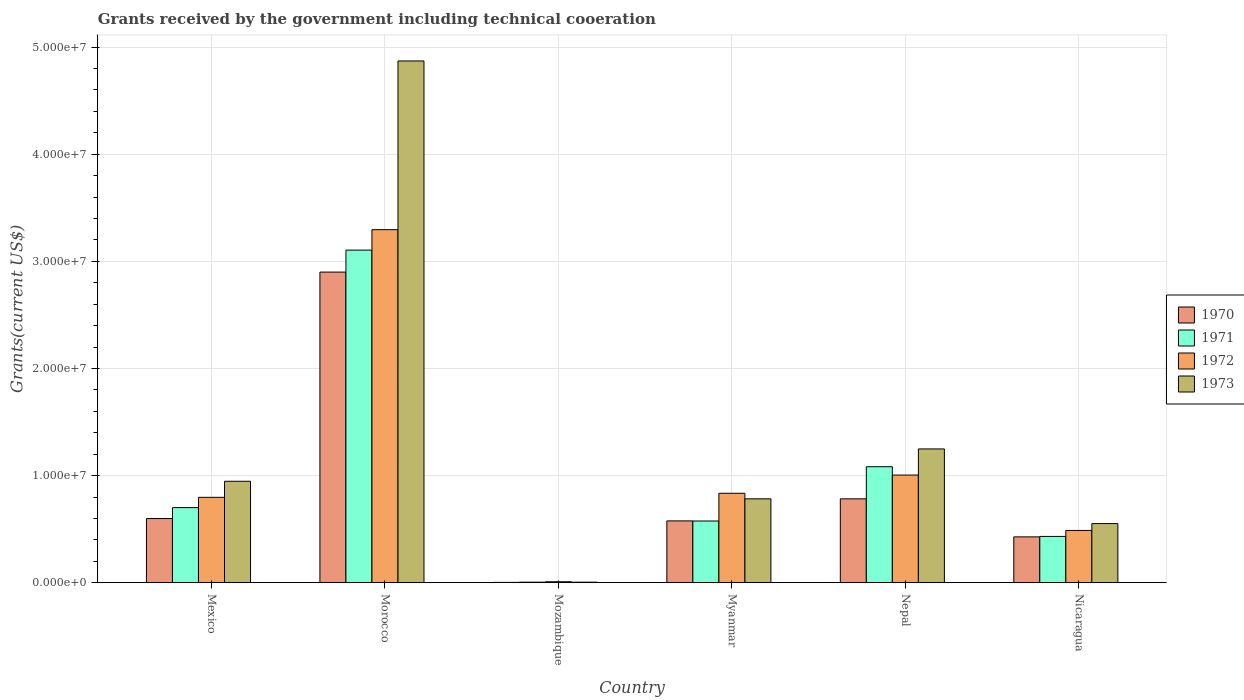Are the number of bars per tick equal to the number of legend labels?
Your response must be concise. Yes. In how many cases, is the number of bars for a given country not equal to the number of legend labels?
Provide a succinct answer. 0. What is the total grants received by the government in 1972 in Mexico?
Make the answer very short. 7.97e+06. Across all countries, what is the maximum total grants received by the government in 1970?
Offer a terse response. 2.90e+07. In which country was the total grants received by the government in 1970 maximum?
Ensure brevity in your answer.  Morocco. In which country was the total grants received by the government in 1971 minimum?
Your answer should be compact. Mozambique. What is the total total grants received by the government in 1971 in the graph?
Offer a very short reply. 5.90e+07. What is the difference between the total grants received by the government in 1972 in Morocco and that in Myanmar?
Provide a short and direct response. 2.46e+07. What is the difference between the total grants received by the government in 1972 in Nepal and the total grants received by the government in 1971 in Mexico?
Offer a very short reply. 3.04e+06. What is the average total grants received by the government in 1973 per country?
Offer a very short reply. 1.40e+07. What is the difference between the total grants received by the government of/in 1973 and total grants received by the government of/in 1972 in Nepal?
Your response must be concise. 2.44e+06. In how many countries, is the total grants received by the government in 1972 greater than 36000000 US$?
Ensure brevity in your answer.  0. What is the ratio of the total grants received by the government in 1970 in Morocco to that in Nicaragua?
Keep it short and to the point. 6.78. What is the difference between the highest and the second highest total grants received by the government in 1973?
Your response must be concise. 3.62e+07. What is the difference between the highest and the lowest total grants received by the government in 1972?
Offer a very short reply. 3.29e+07. Is the sum of the total grants received by the government in 1971 in Mexico and Mozambique greater than the maximum total grants received by the government in 1972 across all countries?
Provide a succinct answer. No. Is it the case that in every country, the sum of the total grants received by the government in 1972 and total grants received by the government in 1970 is greater than the sum of total grants received by the government in 1971 and total grants received by the government in 1973?
Your answer should be compact. No. What does the 4th bar from the right in Nepal represents?
Provide a short and direct response. 1970. How many bars are there?
Offer a very short reply. 24. Does the graph contain grids?
Keep it short and to the point. Yes. Where does the legend appear in the graph?
Your answer should be compact. Center right. What is the title of the graph?
Make the answer very short. Grants received by the government including technical cooeration. Does "2004" appear as one of the legend labels in the graph?
Offer a terse response. No. What is the label or title of the X-axis?
Ensure brevity in your answer.  Country. What is the label or title of the Y-axis?
Offer a terse response. Grants(current US$). What is the Grants(current US$) of 1970 in Mexico?
Provide a short and direct response. 5.99e+06. What is the Grants(current US$) of 1971 in Mexico?
Make the answer very short. 7.01e+06. What is the Grants(current US$) of 1972 in Mexico?
Offer a very short reply. 7.97e+06. What is the Grants(current US$) in 1973 in Mexico?
Offer a terse response. 9.47e+06. What is the Grants(current US$) of 1970 in Morocco?
Give a very brief answer. 2.90e+07. What is the Grants(current US$) of 1971 in Morocco?
Make the answer very short. 3.10e+07. What is the Grants(current US$) in 1972 in Morocco?
Offer a terse response. 3.30e+07. What is the Grants(current US$) of 1973 in Morocco?
Ensure brevity in your answer.  4.87e+07. What is the Grants(current US$) of 1972 in Mozambique?
Keep it short and to the point. 9.00e+04. What is the Grants(current US$) of 1973 in Mozambique?
Ensure brevity in your answer.  5.00e+04. What is the Grants(current US$) in 1970 in Myanmar?
Make the answer very short. 5.77e+06. What is the Grants(current US$) in 1971 in Myanmar?
Your answer should be very brief. 5.76e+06. What is the Grants(current US$) of 1972 in Myanmar?
Offer a very short reply. 8.35e+06. What is the Grants(current US$) in 1973 in Myanmar?
Offer a very short reply. 7.83e+06. What is the Grants(current US$) of 1970 in Nepal?
Make the answer very short. 7.83e+06. What is the Grants(current US$) of 1971 in Nepal?
Offer a very short reply. 1.08e+07. What is the Grants(current US$) in 1972 in Nepal?
Your response must be concise. 1.00e+07. What is the Grants(current US$) in 1973 in Nepal?
Provide a short and direct response. 1.25e+07. What is the Grants(current US$) in 1970 in Nicaragua?
Provide a short and direct response. 4.28e+06. What is the Grants(current US$) in 1971 in Nicaragua?
Your answer should be very brief. 4.32e+06. What is the Grants(current US$) in 1972 in Nicaragua?
Provide a succinct answer. 4.88e+06. What is the Grants(current US$) in 1973 in Nicaragua?
Offer a very short reply. 5.52e+06. Across all countries, what is the maximum Grants(current US$) of 1970?
Provide a short and direct response. 2.90e+07. Across all countries, what is the maximum Grants(current US$) in 1971?
Offer a very short reply. 3.10e+07. Across all countries, what is the maximum Grants(current US$) of 1972?
Provide a succinct answer. 3.30e+07. Across all countries, what is the maximum Grants(current US$) in 1973?
Provide a short and direct response. 4.87e+07. Across all countries, what is the minimum Grants(current US$) of 1970?
Offer a very short reply. 3.00e+04. Across all countries, what is the minimum Grants(current US$) in 1971?
Give a very brief answer. 5.00e+04. Across all countries, what is the minimum Grants(current US$) of 1972?
Keep it short and to the point. 9.00e+04. Across all countries, what is the minimum Grants(current US$) in 1973?
Keep it short and to the point. 5.00e+04. What is the total Grants(current US$) of 1970 in the graph?
Ensure brevity in your answer.  5.29e+07. What is the total Grants(current US$) of 1971 in the graph?
Keep it short and to the point. 5.90e+07. What is the total Grants(current US$) in 1972 in the graph?
Provide a succinct answer. 6.43e+07. What is the total Grants(current US$) in 1973 in the graph?
Ensure brevity in your answer.  8.41e+07. What is the difference between the Grants(current US$) in 1970 in Mexico and that in Morocco?
Give a very brief answer. -2.30e+07. What is the difference between the Grants(current US$) in 1971 in Mexico and that in Morocco?
Your answer should be very brief. -2.40e+07. What is the difference between the Grants(current US$) in 1972 in Mexico and that in Morocco?
Offer a terse response. -2.50e+07. What is the difference between the Grants(current US$) in 1973 in Mexico and that in Morocco?
Provide a short and direct response. -3.92e+07. What is the difference between the Grants(current US$) in 1970 in Mexico and that in Mozambique?
Give a very brief answer. 5.96e+06. What is the difference between the Grants(current US$) of 1971 in Mexico and that in Mozambique?
Offer a very short reply. 6.96e+06. What is the difference between the Grants(current US$) of 1972 in Mexico and that in Mozambique?
Provide a succinct answer. 7.88e+06. What is the difference between the Grants(current US$) of 1973 in Mexico and that in Mozambique?
Offer a terse response. 9.42e+06. What is the difference between the Grants(current US$) in 1971 in Mexico and that in Myanmar?
Provide a short and direct response. 1.25e+06. What is the difference between the Grants(current US$) in 1972 in Mexico and that in Myanmar?
Provide a short and direct response. -3.80e+05. What is the difference between the Grants(current US$) of 1973 in Mexico and that in Myanmar?
Offer a terse response. 1.64e+06. What is the difference between the Grants(current US$) of 1970 in Mexico and that in Nepal?
Offer a terse response. -1.84e+06. What is the difference between the Grants(current US$) of 1971 in Mexico and that in Nepal?
Keep it short and to the point. -3.82e+06. What is the difference between the Grants(current US$) in 1972 in Mexico and that in Nepal?
Provide a short and direct response. -2.08e+06. What is the difference between the Grants(current US$) of 1973 in Mexico and that in Nepal?
Provide a short and direct response. -3.02e+06. What is the difference between the Grants(current US$) of 1970 in Mexico and that in Nicaragua?
Offer a very short reply. 1.71e+06. What is the difference between the Grants(current US$) in 1971 in Mexico and that in Nicaragua?
Your answer should be very brief. 2.69e+06. What is the difference between the Grants(current US$) in 1972 in Mexico and that in Nicaragua?
Your answer should be compact. 3.09e+06. What is the difference between the Grants(current US$) of 1973 in Mexico and that in Nicaragua?
Make the answer very short. 3.95e+06. What is the difference between the Grants(current US$) of 1970 in Morocco and that in Mozambique?
Provide a succinct answer. 2.90e+07. What is the difference between the Grants(current US$) in 1971 in Morocco and that in Mozambique?
Provide a succinct answer. 3.10e+07. What is the difference between the Grants(current US$) in 1972 in Morocco and that in Mozambique?
Offer a very short reply. 3.29e+07. What is the difference between the Grants(current US$) in 1973 in Morocco and that in Mozambique?
Your answer should be compact. 4.87e+07. What is the difference between the Grants(current US$) in 1970 in Morocco and that in Myanmar?
Provide a short and direct response. 2.32e+07. What is the difference between the Grants(current US$) in 1971 in Morocco and that in Myanmar?
Offer a very short reply. 2.53e+07. What is the difference between the Grants(current US$) of 1972 in Morocco and that in Myanmar?
Keep it short and to the point. 2.46e+07. What is the difference between the Grants(current US$) in 1973 in Morocco and that in Myanmar?
Make the answer very short. 4.09e+07. What is the difference between the Grants(current US$) in 1970 in Morocco and that in Nepal?
Give a very brief answer. 2.12e+07. What is the difference between the Grants(current US$) in 1971 in Morocco and that in Nepal?
Provide a succinct answer. 2.02e+07. What is the difference between the Grants(current US$) in 1972 in Morocco and that in Nepal?
Keep it short and to the point. 2.29e+07. What is the difference between the Grants(current US$) of 1973 in Morocco and that in Nepal?
Your response must be concise. 3.62e+07. What is the difference between the Grants(current US$) of 1970 in Morocco and that in Nicaragua?
Your response must be concise. 2.47e+07. What is the difference between the Grants(current US$) in 1971 in Morocco and that in Nicaragua?
Your response must be concise. 2.67e+07. What is the difference between the Grants(current US$) in 1972 in Morocco and that in Nicaragua?
Offer a very short reply. 2.81e+07. What is the difference between the Grants(current US$) of 1973 in Morocco and that in Nicaragua?
Give a very brief answer. 4.32e+07. What is the difference between the Grants(current US$) of 1970 in Mozambique and that in Myanmar?
Ensure brevity in your answer.  -5.74e+06. What is the difference between the Grants(current US$) of 1971 in Mozambique and that in Myanmar?
Provide a succinct answer. -5.71e+06. What is the difference between the Grants(current US$) of 1972 in Mozambique and that in Myanmar?
Your response must be concise. -8.26e+06. What is the difference between the Grants(current US$) of 1973 in Mozambique and that in Myanmar?
Your answer should be compact. -7.78e+06. What is the difference between the Grants(current US$) in 1970 in Mozambique and that in Nepal?
Your answer should be very brief. -7.80e+06. What is the difference between the Grants(current US$) in 1971 in Mozambique and that in Nepal?
Offer a very short reply. -1.08e+07. What is the difference between the Grants(current US$) of 1972 in Mozambique and that in Nepal?
Offer a terse response. -9.96e+06. What is the difference between the Grants(current US$) of 1973 in Mozambique and that in Nepal?
Keep it short and to the point. -1.24e+07. What is the difference between the Grants(current US$) of 1970 in Mozambique and that in Nicaragua?
Your answer should be very brief. -4.25e+06. What is the difference between the Grants(current US$) of 1971 in Mozambique and that in Nicaragua?
Provide a short and direct response. -4.27e+06. What is the difference between the Grants(current US$) in 1972 in Mozambique and that in Nicaragua?
Ensure brevity in your answer.  -4.79e+06. What is the difference between the Grants(current US$) of 1973 in Mozambique and that in Nicaragua?
Make the answer very short. -5.47e+06. What is the difference between the Grants(current US$) of 1970 in Myanmar and that in Nepal?
Offer a terse response. -2.06e+06. What is the difference between the Grants(current US$) of 1971 in Myanmar and that in Nepal?
Ensure brevity in your answer.  -5.07e+06. What is the difference between the Grants(current US$) in 1972 in Myanmar and that in Nepal?
Your answer should be very brief. -1.70e+06. What is the difference between the Grants(current US$) in 1973 in Myanmar and that in Nepal?
Make the answer very short. -4.66e+06. What is the difference between the Grants(current US$) in 1970 in Myanmar and that in Nicaragua?
Offer a terse response. 1.49e+06. What is the difference between the Grants(current US$) in 1971 in Myanmar and that in Nicaragua?
Offer a very short reply. 1.44e+06. What is the difference between the Grants(current US$) of 1972 in Myanmar and that in Nicaragua?
Give a very brief answer. 3.47e+06. What is the difference between the Grants(current US$) of 1973 in Myanmar and that in Nicaragua?
Ensure brevity in your answer.  2.31e+06. What is the difference between the Grants(current US$) of 1970 in Nepal and that in Nicaragua?
Your answer should be compact. 3.55e+06. What is the difference between the Grants(current US$) in 1971 in Nepal and that in Nicaragua?
Offer a very short reply. 6.51e+06. What is the difference between the Grants(current US$) of 1972 in Nepal and that in Nicaragua?
Provide a succinct answer. 5.17e+06. What is the difference between the Grants(current US$) of 1973 in Nepal and that in Nicaragua?
Offer a very short reply. 6.97e+06. What is the difference between the Grants(current US$) in 1970 in Mexico and the Grants(current US$) in 1971 in Morocco?
Provide a succinct answer. -2.51e+07. What is the difference between the Grants(current US$) of 1970 in Mexico and the Grants(current US$) of 1972 in Morocco?
Provide a succinct answer. -2.70e+07. What is the difference between the Grants(current US$) in 1970 in Mexico and the Grants(current US$) in 1973 in Morocco?
Offer a very short reply. -4.27e+07. What is the difference between the Grants(current US$) in 1971 in Mexico and the Grants(current US$) in 1972 in Morocco?
Keep it short and to the point. -2.60e+07. What is the difference between the Grants(current US$) of 1971 in Mexico and the Grants(current US$) of 1973 in Morocco?
Ensure brevity in your answer.  -4.17e+07. What is the difference between the Grants(current US$) of 1972 in Mexico and the Grants(current US$) of 1973 in Morocco?
Make the answer very short. -4.07e+07. What is the difference between the Grants(current US$) in 1970 in Mexico and the Grants(current US$) in 1971 in Mozambique?
Make the answer very short. 5.94e+06. What is the difference between the Grants(current US$) in 1970 in Mexico and the Grants(current US$) in 1972 in Mozambique?
Ensure brevity in your answer.  5.90e+06. What is the difference between the Grants(current US$) of 1970 in Mexico and the Grants(current US$) of 1973 in Mozambique?
Provide a succinct answer. 5.94e+06. What is the difference between the Grants(current US$) of 1971 in Mexico and the Grants(current US$) of 1972 in Mozambique?
Your answer should be compact. 6.92e+06. What is the difference between the Grants(current US$) in 1971 in Mexico and the Grants(current US$) in 1973 in Mozambique?
Offer a very short reply. 6.96e+06. What is the difference between the Grants(current US$) in 1972 in Mexico and the Grants(current US$) in 1973 in Mozambique?
Offer a very short reply. 7.92e+06. What is the difference between the Grants(current US$) in 1970 in Mexico and the Grants(current US$) in 1972 in Myanmar?
Offer a terse response. -2.36e+06. What is the difference between the Grants(current US$) of 1970 in Mexico and the Grants(current US$) of 1973 in Myanmar?
Provide a succinct answer. -1.84e+06. What is the difference between the Grants(current US$) in 1971 in Mexico and the Grants(current US$) in 1972 in Myanmar?
Give a very brief answer. -1.34e+06. What is the difference between the Grants(current US$) of 1971 in Mexico and the Grants(current US$) of 1973 in Myanmar?
Offer a very short reply. -8.20e+05. What is the difference between the Grants(current US$) of 1970 in Mexico and the Grants(current US$) of 1971 in Nepal?
Give a very brief answer. -4.84e+06. What is the difference between the Grants(current US$) of 1970 in Mexico and the Grants(current US$) of 1972 in Nepal?
Offer a terse response. -4.06e+06. What is the difference between the Grants(current US$) in 1970 in Mexico and the Grants(current US$) in 1973 in Nepal?
Provide a succinct answer. -6.50e+06. What is the difference between the Grants(current US$) in 1971 in Mexico and the Grants(current US$) in 1972 in Nepal?
Your answer should be very brief. -3.04e+06. What is the difference between the Grants(current US$) in 1971 in Mexico and the Grants(current US$) in 1973 in Nepal?
Keep it short and to the point. -5.48e+06. What is the difference between the Grants(current US$) in 1972 in Mexico and the Grants(current US$) in 1973 in Nepal?
Make the answer very short. -4.52e+06. What is the difference between the Grants(current US$) in 1970 in Mexico and the Grants(current US$) in 1971 in Nicaragua?
Ensure brevity in your answer.  1.67e+06. What is the difference between the Grants(current US$) in 1970 in Mexico and the Grants(current US$) in 1972 in Nicaragua?
Offer a very short reply. 1.11e+06. What is the difference between the Grants(current US$) in 1970 in Mexico and the Grants(current US$) in 1973 in Nicaragua?
Give a very brief answer. 4.70e+05. What is the difference between the Grants(current US$) of 1971 in Mexico and the Grants(current US$) of 1972 in Nicaragua?
Give a very brief answer. 2.13e+06. What is the difference between the Grants(current US$) of 1971 in Mexico and the Grants(current US$) of 1973 in Nicaragua?
Your response must be concise. 1.49e+06. What is the difference between the Grants(current US$) in 1972 in Mexico and the Grants(current US$) in 1973 in Nicaragua?
Ensure brevity in your answer.  2.45e+06. What is the difference between the Grants(current US$) in 1970 in Morocco and the Grants(current US$) in 1971 in Mozambique?
Your response must be concise. 2.90e+07. What is the difference between the Grants(current US$) in 1970 in Morocco and the Grants(current US$) in 1972 in Mozambique?
Give a very brief answer. 2.89e+07. What is the difference between the Grants(current US$) of 1970 in Morocco and the Grants(current US$) of 1973 in Mozambique?
Keep it short and to the point. 2.90e+07. What is the difference between the Grants(current US$) in 1971 in Morocco and the Grants(current US$) in 1972 in Mozambique?
Provide a succinct answer. 3.10e+07. What is the difference between the Grants(current US$) of 1971 in Morocco and the Grants(current US$) of 1973 in Mozambique?
Your answer should be compact. 3.10e+07. What is the difference between the Grants(current US$) in 1972 in Morocco and the Grants(current US$) in 1973 in Mozambique?
Your answer should be very brief. 3.29e+07. What is the difference between the Grants(current US$) in 1970 in Morocco and the Grants(current US$) in 1971 in Myanmar?
Provide a short and direct response. 2.32e+07. What is the difference between the Grants(current US$) of 1970 in Morocco and the Grants(current US$) of 1972 in Myanmar?
Give a very brief answer. 2.06e+07. What is the difference between the Grants(current US$) in 1970 in Morocco and the Grants(current US$) in 1973 in Myanmar?
Provide a short and direct response. 2.12e+07. What is the difference between the Grants(current US$) in 1971 in Morocco and the Grants(current US$) in 1972 in Myanmar?
Provide a short and direct response. 2.27e+07. What is the difference between the Grants(current US$) in 1971 in Morocco and the Grants(current US$) in 1973 in Myanmar?
Provide a short and direct response. 2.32e+07. What is the difference between the Grants(current US$) in 1972 in Morocco and the Grants(current US$) in 1973 in Myanmar?
Offer a very short reply. 2.51e+07. What is the difference between the Grants(current US$) in 1970 in Morocco and the Grants(current US$) in 1971 in Nepal?
Keep it short and to the point. 1.82e+07. What is the difference between the Grants(current US$) in 1970 in Morocco and the Grants(current US$) in 1972 in Nepal?
Ensure brevity in your answer.  1.90e+07. What is the difference between the Grants(current US$) in 1970 in Morocco and the Grants(current US$) in 1973 in Nepal?
Provide a short and direct response. 1.65e+07. What is the difference between the Grants(current US$) of 1971 in Morocco and the Grants(current US$) of 1972 in Nepal?
Offer a very short reply. 2.10e+07. What is the difference between the Grants(current US$) in 1971 in Morocco and the Grants(current US$) in 1973 in Nepal?
Ensure brevity in your answer.  1.86e+07. What is the difference between the Grants(current US$) of 1972 in Morocco and the Grants(current US$) of 1973 in Nepal?
Your answer should be compact. 2.05e+07. What is the difference between the Grants(current US$) of 1970 in Morocco and the Grants(current US$) of 1971 in Nicaragua?
Your answer should be very brief. 2.47e+07. What is the difference between the Grants(current US$) in 1970 in Morocco and the Grants(current US$) in 1972 in Nicaragua?
Give a very brief answer. 2.41e+07. What is the difference between the Grants(current US$) in 1970 in Morocco and the Grants(current US$) in 1973 in Nicaragua?
Ensure brevity in your answer.  2.35e+07. What is the difference between the Grants(current US$) in 1971 in Morocco and the Grants(current US$) in 1972 in Nicaragua?
Offer a very short reply. 2.62e+07. What is the difference between the Grants(current US$) of 1971 in Morocco and the Grants(current US$) of 1973 in Nicaragua?
Offer a terse response. 2.55e+07. What is the difference between the Grants(current US$) of 1972 in Morocco and the Grants(current US$) of 1973 in Nicaragua?
Make the answer very short. 2.74e+07. What is the difference between the Grants(current US$) in 1970 in Mozambique and the Grants(current US$) in 1971 in Myanmar?
Keep it short and to the point. -5.73e+06. What is the difference between the Grants(current US$) in 1970 in Mozambique and the Grants(current US$) in 1972 in Myanmar?
Provide a short and direct response. -8.32e+06. What is the difference between the Grants(current US$) in 1970 in Mozambique and the Grants(current US$) in 1973 in Myanmar?
Provide a short and direct response. -7.80e+06. What is the difference between the Grants(current US$) of 1971 in Mozambique and the Grants(current US$) of 1972 in Myanmar?
Your answer should be compact. -8.30e+06. What is the difference between the Grants(current US$) in 1971 in Mozambique and the Grants(current US$) in 1973 in Myanmar?
Offer a very short reply. -7.78e+06. What is the difference between the Grants(current US$) in 1972 in Mozambique and the Grants(current US$) in 1973 in Myanmar?
Keep it short and to the point. -7.74e+06. What is the difference between the Grants(current US$) of 1970 in Mozambique and the Grants(current US$) of 1971 in Nepal?
Offer a very short reply. -1.08e+07. What is the difference between the Grants(current US$) of 1970 in Mozambique and the Grants(current US$) of 1972 in Nepal?
Your answer should be compact. -1.00e+07. What is the difference between the Grants(current US$) of 1970 in Mozambique and the Grants(current US$) of 1973 in Nepal?
Ensure brevity in your answer.  -1.25e+07. What is the difference between the Grants(current US$) in 1971 in Mozambique and the Grants(current US$) in 1972 in Nepal?
Ensure brevity in your answer.  -1.00e+07. What is the difference between the Grants(current US$) of 1971 in Mozambique and the Grants(current US$) of 1973 in Nepal?
Keep it short and to the point. -1.24e+07. What is the difference between the Grants(current US$) of 1972 in Mozambique and the Grants(current US$) of 1973 in Nepal?
Your answer should be compact. -1.24e+07. What is the difference between the Grants(current US$) in 1970 in Mozambique and the Grants(current US$) in 1971 in Nicaragua?
Provide a succinct answer. -4.29e+06. What is the difference between the Grants(current US$) of 1970 in Mozambique and the Grants(current US$) of 1972 in Nicaragua?
Offer a very short reply. -4.85e+06. What is the difference between the Grants(current US$) of 1970 in Mozambique and the Grants(current US$) of 1973 in Nicaragua?
Keep it short and to the point. -5.49e+06. What is the difference between the Grants(current US$) of 1971 in Mozambique and the Grants(current US$) of 1972 in Nicaragua?
Keep it short and to the point. -4.83e+06. What is the difference between the Grants(current US$) in 1971 in Mozambique and the Grants(current US$) in 1973 in Nicaragua?
Provide a short and direct response. -5.47e+06. What is the difference between the Grants(current US$) of 1972 in Mozambique and the Grants(current US$) of 1973 in Nicaragua?
Your answer should be compact. -5.43e+06. What is the difference between the Grants(current US$) in 1970 in Myanmar and the Grants(current US$) in 1971 in Nepal?
Keep it short and to the point. -5.06e+06. What is the difference between the Grants(current US$) in 1970 in Myanmar and the Grants(current US$) in 1972 in Nepal?
Your answer should be very brief. -4.28e+06. What is the difference between the Grants(current US$) in 1970 in Myanmar and the Grants(current US$) in 1973 in Nepal?
Your answer should be very brief. -6.72e+06. What is the difference between the Grants(current US$) in 1971 in Myanmar and the Grants(current US$) in 1972 in Nepal?
Your response must be concise. -4.29e+06. What is the difference between the Grants(current US$) in 1971 in Myanmar and the Grants(current US$) in 1973 in Nepal?
Your response must be concise. -6.73e+06. What is the difference between the Grants(current US$) in 1972 in Myanmar and the Grants(current US$) in 1973 in Nepal?
Your answer should be compact. -4.14e+06. What is the difference between the Grants(current US$) in 1970 in Myanmar and the Grants(current US$) in 1971 in Nicaragua?
Offer a terse response. 1.45e+06. What is the difference between the Grants(current US$) of 1970 in Myanmar and the Grants(current US$) of 1972 in Nicaragua?
Offer a very short reply. 8.90e+05. What is the difference between the Grants(current US$) in 1971 in Myanmar and the Grants(current US$) in 1972 in Nicaragua?
Your answer should be very brief. 8.80e+05. What is the difference between the Grants(current US$) of 1971 in Myanmar and the Grants(current US$) of 1973 in Nicaragua?
Provide a succinct answer. 2.40e+05. What is the difference between the Grants(current US$) in 1972 in Myanmar and the Grants(current US$) in 1973 in Nicaragua?
Offer a terse response. 2.83e+06. What is the difference between the Grants(current US$) of 1970 in Nepal and the Grants(current US$) of 1971 in Nicaragua?
Your response must be concise. 3.51e+06. What is the difference between the Grants(current US$) of 1970 in Nepal and the Grants(current US$) of 1972 in Nicaragua?
Provide a short and direct response. 2.95e+06. What is the difference between the Grants(current US$) of 1970 in Nepal and the Grants(current US$) of 1973 in Nicaragua?
Offer a very short reply. 2.31e+06. What is the difference between the Grants(current US$) in 1971 in Nepal and the Grants(current US$) in 1972 in Nicaragua?
Give a very brief answer. 5.95e+06. What is the difference between the Grants(current US$) in 1971 in Nepal and the Grants(current US$) in 1973 in Nicaragua?
Your response must be concise. 5.31e+06. What is the difference between the Grants(current US$) of 1972 in Nepal and the Grants(current US$) of 1973 in Nicaragua?
Provide a succinct answer. 4.53e+06. What is the average Grants(current US$) in 1970 per country?
Make the answer very short. 8.82e+06. What is the average Grants(current US$) of 1971 per country?
Provide a succinct answer. 9.84e+06. What is the average Grants(current US$) of 1972 per country?
Ensure brevity in your answer.  1.07e+07. What is the average Grants(current US$) in 1973 per country?
Provide a succinct answer. 1.40e+07. What is the difference between the Grants(current US$) in 1970 and Grants(current US$) in 1971 in Mexico?
Your answer should be very brief. -1.02e+06. What is the difference between the Grants(current US$) in 1970 and Grants(current US$) in 1972 in Mexico?
Give a very brief answer. -1.98e+06. What is the difference between the Grants(current US$) of 1970 and Grants(current US$) of 1973 in Mexico?
Your answer should be compact. -3.48e+06. What is the difference between the Grants(current US$) in 1971 and Grants(current US$) in 1972 in Mexico?
Keep it short and to the point. -9.60e+05. What is the difference between the Grants(current US$) of 1971 and Grants(current US$) of 1973 in Mexico?
Your answer should be compact. -2.46e+06. What is the difference between the Grants(current US$) in 1972 and Grants(current US$) in 1973 in Mexico?
Give a very brief answer. -1.50e+06. What is the difference between the Grants(current US$) in 1970 and Grants(current US$) in 1971 in Morocco?
Your response must be concise. -2.05e+06. What is the difference between the Grants(current US$) of 1970 and Grants(current US$) of 1972 in Morocco?
Ensure brevity in your answer.  -3.96e+06. What is the difference between the Grants(current US$) in 1970 and Grants(current US$) in 1973 in Morocco?
Make the answer very short. -1.97e+07. What is the difference between the Grants(current US$) in 1971 and Grants(current US$) in 1972 in Morocco?
Give a very brief answer. -1.91e+06. What is the difference between the Grants(current US$) in 1971 and Grants(current US$) in 1973 in Morocco?
Your answer should be compact. -1.77e+07. What is the difference between the Grants(current US$) of 1972 and Grants(current US$) of 1973 in Morocco?
Ensure brevity in your answer.  -1.58e+07. What is the difference between the Grants(current US$) in 1970 and Grants(current US$) in 1971 in Mozambique?
Make the answer very short. -2.00e+04. What is the difference between the Grants(current US$) in 1970 and Grants(current US$) in 1973 in Mozambique?
Offer a terse response. -2.00e+04. What is the difference between the Grants(current US$) of 1971 and Grants(current US$) of 1972 in Mozambique?
Your answer should be very brief. -4.00e+04. What is the difference between the Grants(current US$) of 1970 and Grants(current US$) of 1971 in Myanmar?
Your response must be concise. 10000. What is the difference between the Grants(current US$) of 1970 and Grants(current US$) of 1972 in Myanmar?
Ensure brevity in your answer.  -2.58e+06. What is the difference between the Grants(current US$) of 1970 and Grants(current US$) of 1973 in Myanmar?
Keep it short and to the point. -2.06e+06. What is the difference between the Grants(current US$) in 1971 and Grants(current US$) in 1972 in Myanmar?
Offer a terse response. -2.59e+06. What is the difference between the Grants(current US$) in 1971 and Grants(current US$) in 1973 in Myanmar?
Provide a succinct answer. -2.07e+06. What is the difference between the Grants(current US$) of 1972 and Grants(current US$) of 1973 in Myanmar?
Provide a short and direct response. 5.20e+05. What is the difference between the Grants(current US$) of 1970 and Grants(current US$) of 1972 in Nepal?
Your answer should be compact. -2.22e+06. What is the difference between the Grants(current US$) of 1970 and Grants(current US$) of 1973 in Nepal?
Your response must be concise. -4.66e+06. What is the difference between the Grants(current US$) in 1971 and Grants(current US$) in 1972 in Nepal?
Provide a succinct answer. 7.80e+05. What is the difference between the Grants(current US$) in 1971 and Grants(current US$) in 1973 in Nepal?
Ensure brevity in your answer.  -1.66e+06. What is the difference between the Grants(current US$) in 1972 and Grants(current US$) in 1973 in Nepal?
Give a very brief answer. -2.44e+06. What is the difference between the Grants(current US$) of 1970 and Grants(current US$) of 1972 in Nicaragua?
Offer a terse response. -6.00e+05. What is the difference between the Grants(current US$) in 1970 and Grants(current US$) in 1973 in Nicaragua?
Provide a succinct answer. -1.24e+06. What is the difference between the Grants(current US$) of 1971 and Grants(current US$) of 1972 in Nicaragua?
Offer a terse response. -5.60e+05. What is the difference between the Grants(current US$) in 1971 and Grants(current US$) in 1973 in Nicaragua?
Offer a terse response. -1.20e+06. What is the difference between the Grants(current US$) in 1972 and Grants(current US$) in 1973 in Nicaragua?
Provide a short and direct response. -6.40e+05. What is the ratio of the Grants(current US$) in 1970 in Mexico to that in Morocco?
Provide a succinct answer. 0.21. What is the ratio of the Grants(current US$) of 1971 in Mexico to that in Morocco?
Your response must be concise. 0.23. What is the ratio of the Grants(current US$) in 1972 in Mexico to that in Morocco?
Provide a succinct answer. 0.24. What is the ratio of the Grants(current US$) of 1973 in Mexico to that in Morocco?
Offer a terse response. 0.19. What is the ratio of the Grants(current US$) of 1970 in Mexico to that in Mozambique?
Offer a terse response. 199.67. What is the ratio of the Grants(current US$) of 1971 in Mexico to that in Mozambique?
Offer a very short reply. 140.2. What is the ratio of the Grants(current US$) in 1972 in Mexico to that in Mozambique?
Ensure brevity in your answer.  88.56. What is the ratio of the Grants(current US$) of 1973 in Mexico to that in Mozambique?
Provide a short and direct response. 189.4. What is the ratio of the Grants(current US$) of 1970 in Mexico to that in Myanmar?
Your answer should be very brief. 1.04. What is the ratio of the Grants(current US$) of 1971 in Mexico to that in Myanmar?
Keep it short and to the point. 1.22. What is the ratio of the Grants(current US$) in 1972 in Mexico to that in Myanmar?
Provide a succinct answer. 0.95. What is the ratio of the Grants(current US$) in 1973 in Mexico to that in Myanmar?
Your answer should be very brief. 1.21. What is the ratio of the Grants(current US$) in 1970 in Mexico to that in Nepal?
Provide a succinct answer. 0.77. What is the ratio of the Grants(current US$) of 1971 in Mexico to that in Nepal?
Provide a short and direct response. 0.65. What is the ratio of the Grants(current US$) in 1972 in Mexico to that in Nepal?
Your answer should be compact. 0.79. What is the ratio of the Grants(current US$) of 1973 in Mexico to that in Nepal?
Offer a terse response. 0.76. What is the ratio of the Grants(current US$) of 1970 in Mexico to that in Nicaragua?
Offer a terse response. 1.4. What is the ratio of the Grants(current US$) in 1971 in Mexico to that in Nicaragua?
Your answer should be very brief. 1.62. What is the ratio of the Grants(current US$) in 1972 in Mexico to that in Nicaragua?
Provide a short and direct response. 1.63. What is the ratio of the Grants(current US$) of 1973 in Mexico to that in Nicaragua?
Your answer should be very brief. 1.72. What is the ratio of the Grants(current US$) of 1970 in Morocco to that in Mozambique?
Your response must be concise. 966.67. What is the ratio of the Grants(current US$) of 1971 in Morocco to that in Mozambique?
Your response must be concise. 621. What is the ratio of the Grants(current US$) in 1972 in Morocco to that in Mozambique?
Make the answer very short. 366.22. What is the ratio of the Grants(current US$) in 1973 in Morocco to that in Mozambique?
Keep it short and to the point. 974.2. What is the ratio of the Grants(current US$) of 1970 in Morocco to that in Myanmar?
Offer a terse response. 5.03. What is the ratio of the Grants(current US$) in 1971 in Morocco to that in Myanmar?
Your answer should be very brief. 5.39. What is the ratio of the Grants(current US$) in 1972 in Morocco to that in Myanmar?
Keep it short and to the point. 3.95. What is the ratio of the Grants(current US$) in 1973 in Morocco to that in Myanmar?
Make the answer very short. 6.22. What is the ratio of the Grants(current US$) in 1970 in Morocco to that in Nepal?
Keep it short and to the point. 3.7. What is the ratio of the Grants(current US$) in 1971 in Morocco to that in Nepal?
Offer a terse response. 2.87. What is the ratio of the Grants(current US$) of 1972 in Morocco to that in Nepal?
Offer a terse response. 3.28. What is the ratio of the Grants(current US$) of 1973 in Morocco to that in Nepal?
Provide a short and direct response. 3.9. What is the ratio of the Grants(current US$) in 1970 in Morocco to that in Nicaragua?
Offer a very short reply. 6.78. What is the ratio of the Grants(current US$) of 1971 in Morocco to that in Nicaragua?
Keep it short and to the point. 7.19. What is the ratio of the Grants(current US$) in 1972 in Morocco to that in Nicaragua?
Make the answer very short. 6.75. What is the ratio of the Grants(current US$) in 1973 in Morocco to that in Nicaragua?
Offer a very short reply. 8.82. What is the ratio of the Grants(current US$) in 1970 in Mozambique to that in Myanmar?
Provide a short and direct response. 0.01. What is the ratio of the Grants(current US$) in 1971 in Mozambique to that in Myanmar?
Provide a short and direct response. 0.01. What is the ratio of the Grants(current US$) in 1972 in Mozambique to that in Myanmar?
Provide a short and direct response. 0.01. What is the ratio of the Grants(current US$) in 1973 in Mozambique to that in Myanmar?
Your answer should be very brief. 0.01. What is the ratio of the Grants(current US$) in 1970 in Mozambique to that in Nepal?
Provide a short and direct response. 0. What is the ratio of the Grants(current US$) in 1971 in Mozambique to that in Nepal?
Provide a succinct answer. 0. What is the ratio of the Grants(current US$) in 1972 in Mozambique to that in Nepal?
Make the answer very short. 0.01. What is the ratio of the Grants(current US$) of 1973 in Mozambique to that in Nepal?
Ensure brevity in your answer.  0. What is the ratio of the Grants(current US$) in 1970 in Mozambique to that in Nicaragua?
Your answer should be compact. 0.01. What is the ratio of the Grants(current US$) of 1971 in Mozambique to that in Nicaragua?
Your answer should be very brief. 0.01. What is the ratio of the Grants(current US$) in 1972 in Mozambique to that in Nicaragua?
Provide a short and direct response. 0.02. What is the ratio of the Grants(current US$) of 1973 in Mozambique to that in Nicaragua?
Give a very brief answer. 0.01. What is the ratio of the Grants(current US$) of 1970 in Myanmar to that in Nepal?
Make the answer very short. 0.74. What is the ratio of the Grants(current US$) of 1971 in Myanmar to that in Nepal?
Give a very brief answer. 0.53. What is the ratio of the Grants(current US$) in 1972 in Myanmar to that in Nepal?
Your answer should be very brief. 0.83. What is the ratio of the Grants(current US$) of 1973 in Myanmar to that in Nepal?
Provide a succinct answer. 0.63. What is the ratio of the Grants(current US$) in 1970 in Myanmar to that in Nicaragua?
Offer a terse response. 1.35. What is the ratio of the Grants(current US$) of 1971 in Myanmar to that in Nicaragua?
Provide a succinct answer. 1.33. What is the ratio of the Grants(current US$) in 1972 in Myanmar to that in Nicaragua?
Offer a terse response. 1.71. What is the ratio of the Grants(current US$) of 1973 in Myanmar to that in Nicaragua?
Your answer should be compact. 1.42. What is the ratio of the Grants(current US$) of 1970 in Nepal to that in Nicaragua?
Offer a terse response. 1.83. What is the ratio of the Grants(current US$) of 1971 in Nepal to that in Nicaragua?
Keep it short and to the point. 2.51. What is the ratio of the Grants(current US$) in 1972 in Nepal to that in Nicaragua?
Your response must be concise. 2.06. What is the ratio of the Grants(current US$) in 1973 in Nepal to that in Nicaragua?
Your answer should be very brief. 2.26. What is the difference between the highest and the second highest Grants(current US$) in 1970?
Offer a very short reply. 2.12e+07. What is the difference between the highest and the second highest Grants(current US$) of 1971?
Provide a succinct answer. 2.02e+07. What is the difference between the highest and the second highest Grants(current US$) of 1972?
Provide a succinct answer. 2.29e+07. What is the difference between the highest and the second highest Grants(current US$) of 1973?
Provide a succinct answer. 3.62e+07. What is the difference between the highest and the lowest Grants(current US$) of 1970?
Your answer should be very brief. 2.90e+07. What is the difference between the highest and the lowest Grants(current US$) of 1971?
Give a very brief answer. 3.10e+07. What is the difference between the highest and the lowest Grants(current US$) in 1972?
Give a very brief answer. 3.29e+07. What is the difference between the highest and the lowest Grants(current US$) in 1973?
Keep it short and to the point. 4.87e+07. 